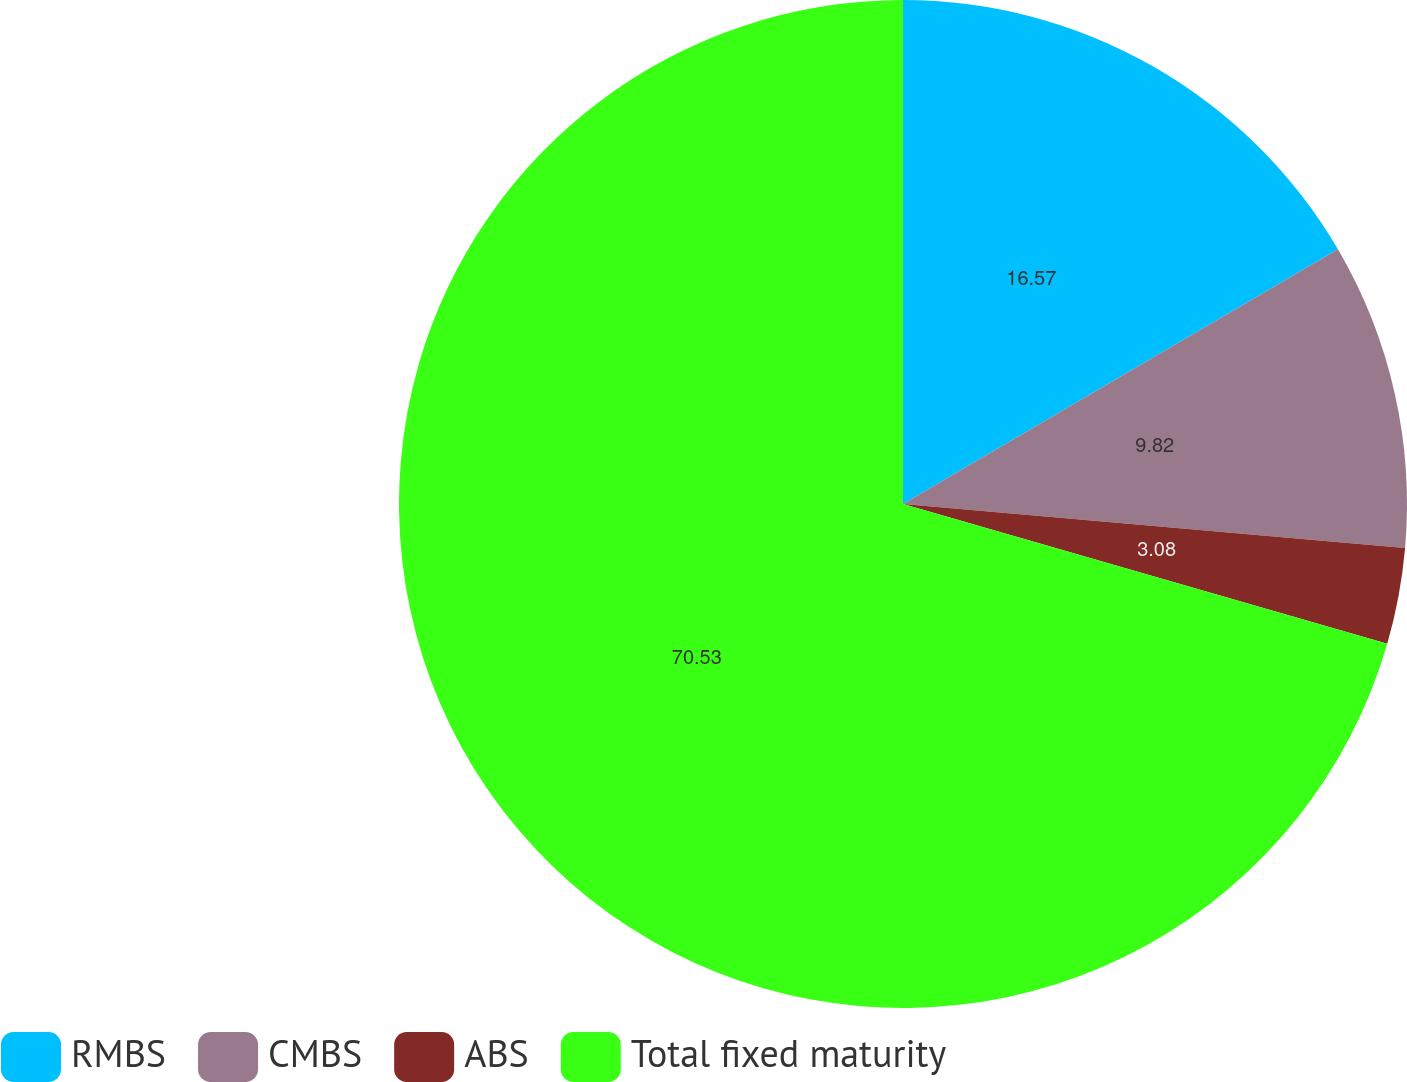Convert chart. <chart><loc_0><loc_0><loc_500><loc_500><pie_chart><fcel>RMBS<fcel>CMBS<fcel>ABS<fcel>Total fixed maturity<nl><fcel>16.57%<fcel>9.82%<fcel>3.08%<fcel>70.53%<nl></chart> 